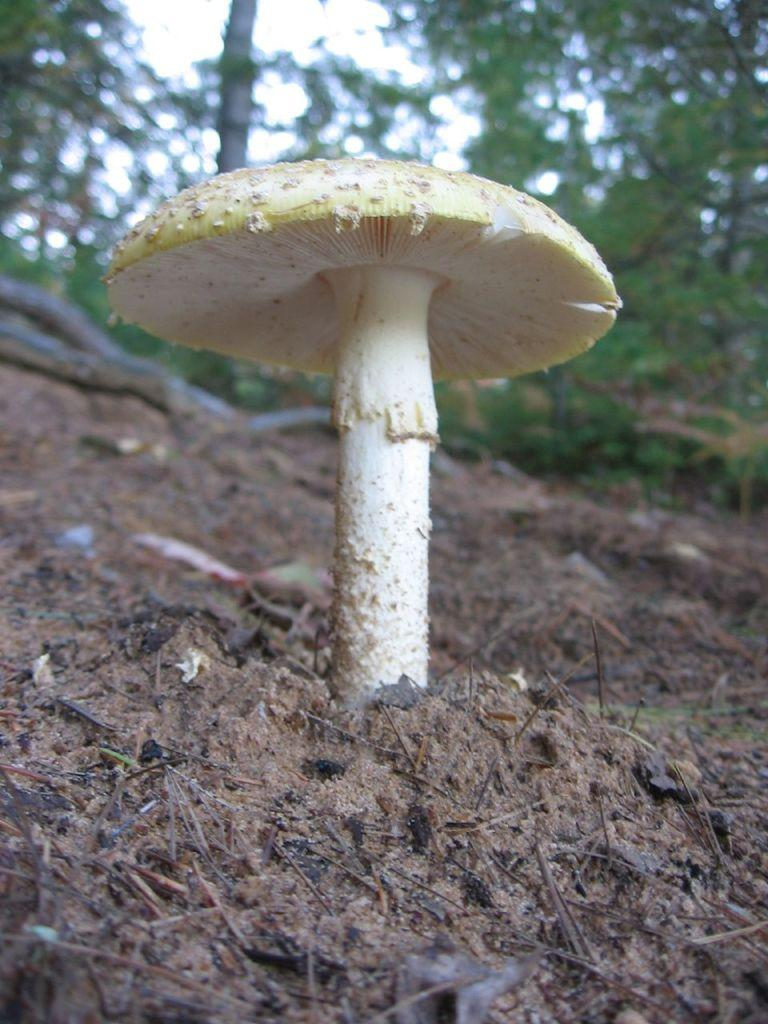What is the main subject of the picture? The main subject of the picture is a mushroom. Where is the mushroom located in the picture? The mushroom is on the ground. What is the color of the mushroom? The mushroom is white in color. What else can be seen in the picture besides the mushroom? There are trees and tree bark visible on the ground in the picture. What type of government is depicted in the picture? There is no government depicted in the picture; it features a mushroom on the ground with trees and tree bark visible. 